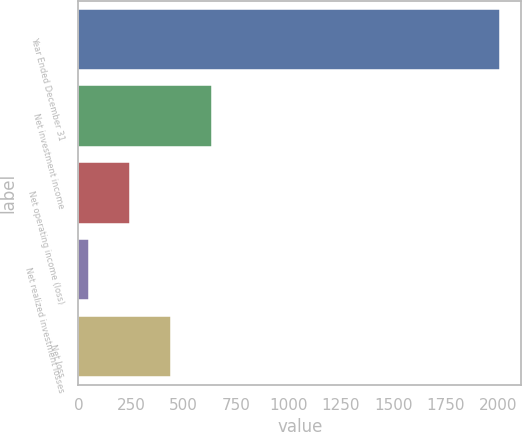Convert chart to OTSL. <chart><loc_0><loc_0><loc_500><loc_500><bar_chart><fcel>Year Ended December 31<fcel>Net investment income<fcel>Net operating income (loss)<fcel>Net realized investment losses<fcel>Net loss<nl><fcel>2009<fcel>636.3<fcel>244.1<fcel>48<fcel>440.2<nl></chart> 